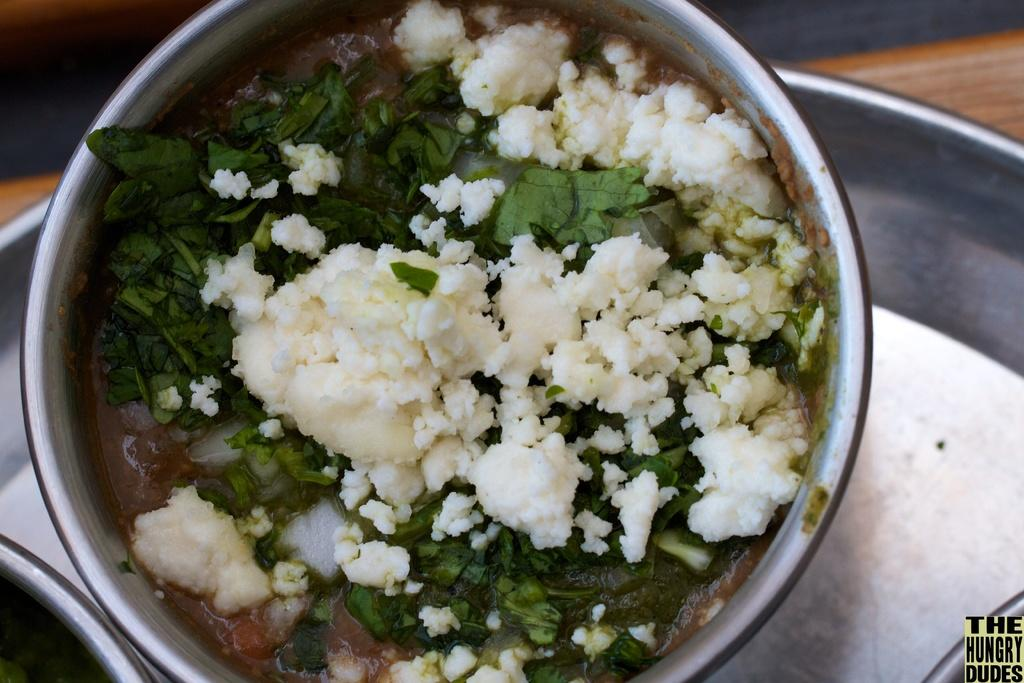What is in the bowl that is visible in the image? There is a bowl with food items in the image. What other items can be seen on the surface in the image? There is a plate on the surface in the image. What suggestion does the bowl of food provide in the image? The bowl of food does not provide any suggestions in the image; it is simply a bowl of food. 